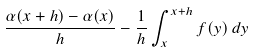<formula> <loc_0><loc_0><loc_500><loc_500>\frac { \alpha ( x + h ) - \alpha ( x ) } { h } - \frac { 1 } { h } \int _ { x } ^ { x + h } f ( y ) \, d y</formula> 